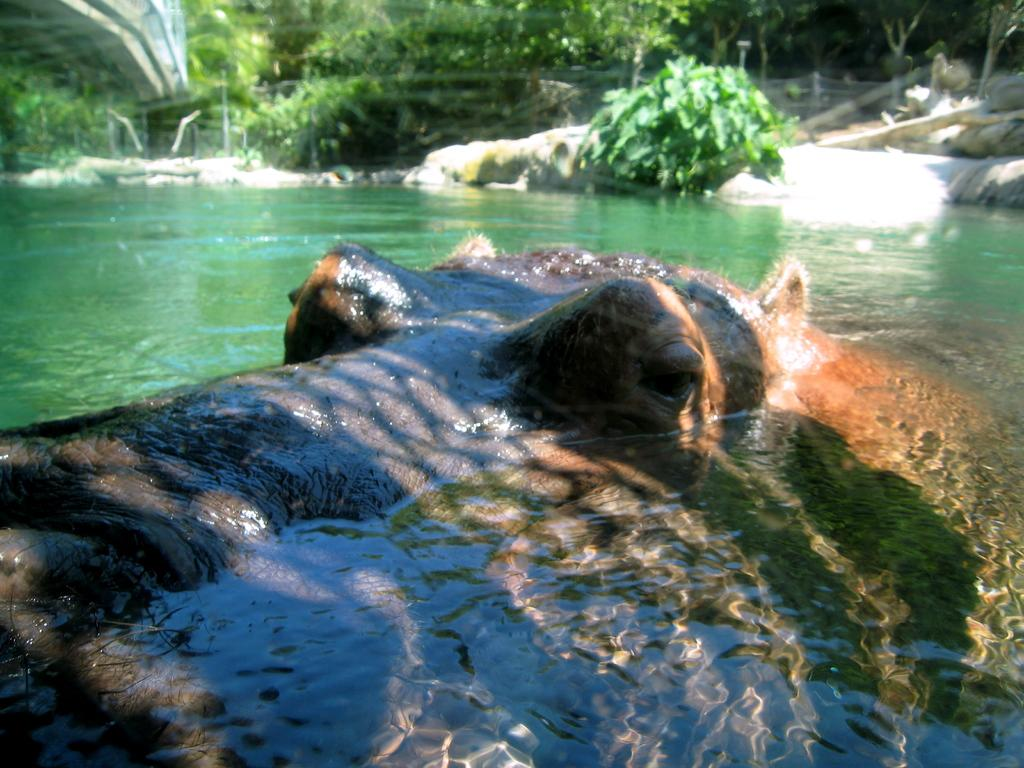What is the main subject of the image? There is an object that resembles a hippopotamus in the image. What can be seen in the background of the image? There are trees visible at the top of the image. What is the price of the baby playing on the playground in the image? There is no baby or playground present in the image, and therefore no price can be determined. 